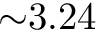Convert formula to latex. <formula><loc_0><loc_0><loc_500><loc_500>{ \sim } 3 . 2 4</formula> 